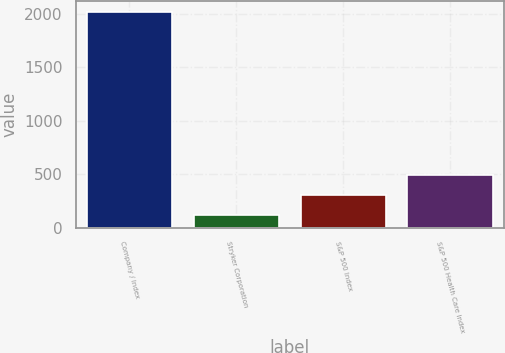Convert chart to OTSL. <chart><loc_0><loc_0><loc_500><loc_500><bar_chart><fcel>Company / Index<fcel>Stryker Corporation<fcel>S&P 500 Index<fcel>S&P 500 Health Care Index<nl><fcel>2012<fcel>113.54<fcel>303.39<fcel>493.24<nl></chart> 